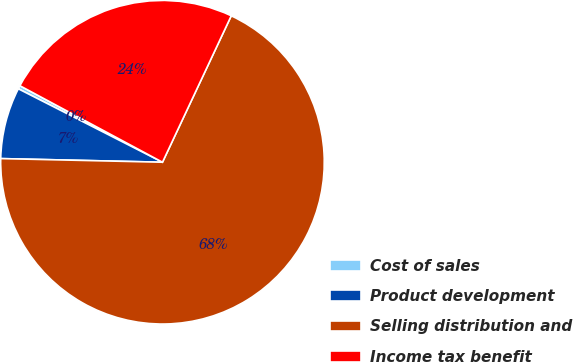Convert chart to OTSL. <chart><loc_0><loc_0><loc_500><loc_500><pie_chart><fcel>Cost of sales<fcel>Product development<fcel>Selling distribution and<fcel>Income tax benefit<nl><fcel>0.34%<fcel>7.14%<fcel>68.37%<fcel>24.15%<nl></chart> 